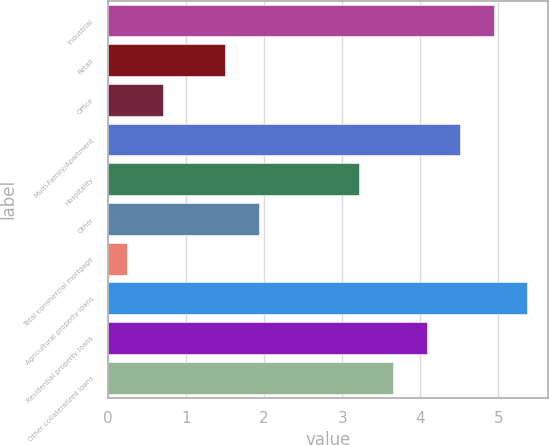Convert chart to OTSL. <chart><loc_0><loc_0><loc_500><loc_500><bar_chart><fcel>Industrial<fcel>Retail<fcel>Office<fcel>Multi-Family/Apartment<fcel>Hospitality<fcel>Other<fcel>Total commercial mortgage<fcel>Agricultural property loans<fcel>Residential property loans<fcel>Other collateralized loans<nl><fcel>4.94<fcel>1.5<fcel>0.7<fcel>4.51<fcel>3.22<fcel>1.93<fcel>0.24<fcel>5.37<fcel>4.08<fcel>3.65<nl></chart> 